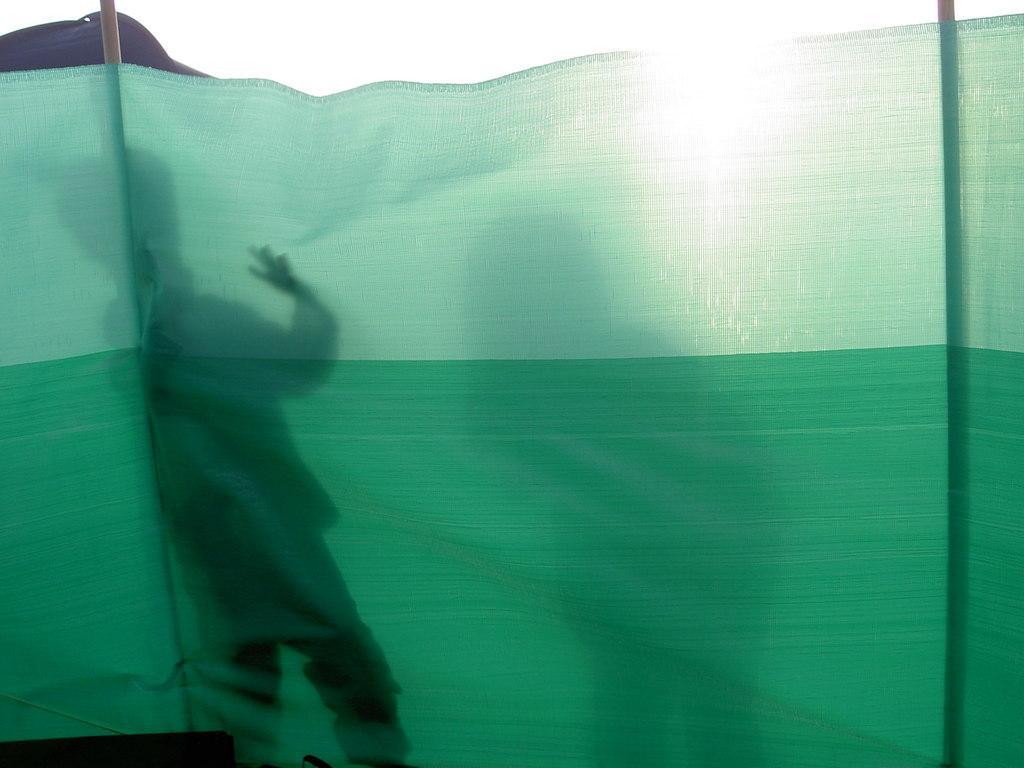In one or two sentences, can you explain what this image depicts? In this image I can see green colour cloth and I can also see shadows. 